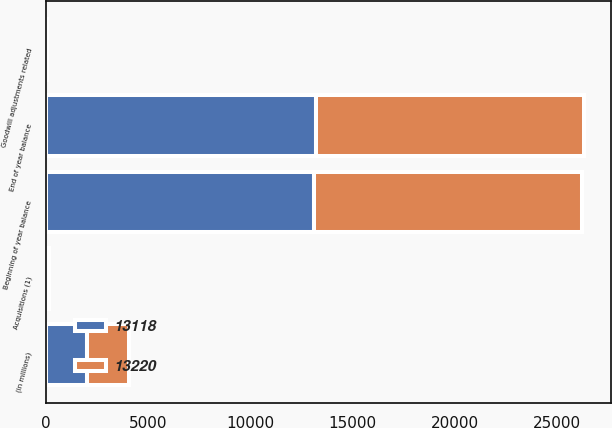<chart> <loc_0><loc_0><loc_500><loc_500><stacked_bar_chart><ecel><fcel>(in millions)<fcel>Beginning of year balance<fcel>Acquisitions (1)<fcel>Goodwill adjustments related<fcel>End of year balance<nl><fcel>13118<fcel>2017<fcel>13118<fcel>121<fcel>19<fcel>13220<nl><fcel>13220<fcel>2016<fcel>13123<fcel>14<fcel>19<fcel>13118<nl></chart> 